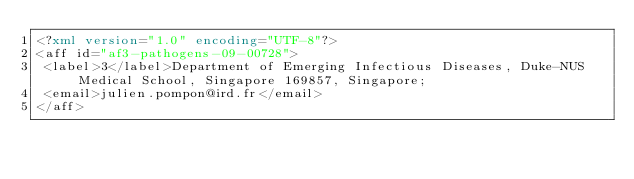<code> <loc_0><loc_0><loc_500><loc_500><_XML_><?xml version="1.0" encoding="UTF-8"?>
<aff id="af3-pathogens-09-00728">
 <label>3</label>Department of Emerging Infectious Diseases, Duke-NUS Medical School, Singapore 169857, Singapore; 
 <email>julien.pompon@ird.fr</email>
</aff>
</code> 